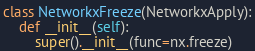Convert code to text. <code><loc_0><loc_0><loc_500><loc_500><_Python_>

class NetworkxFreeze(NetworkxApply):
    def __init__(self):
        super().__init__(func=nx.freeze)
</code> 